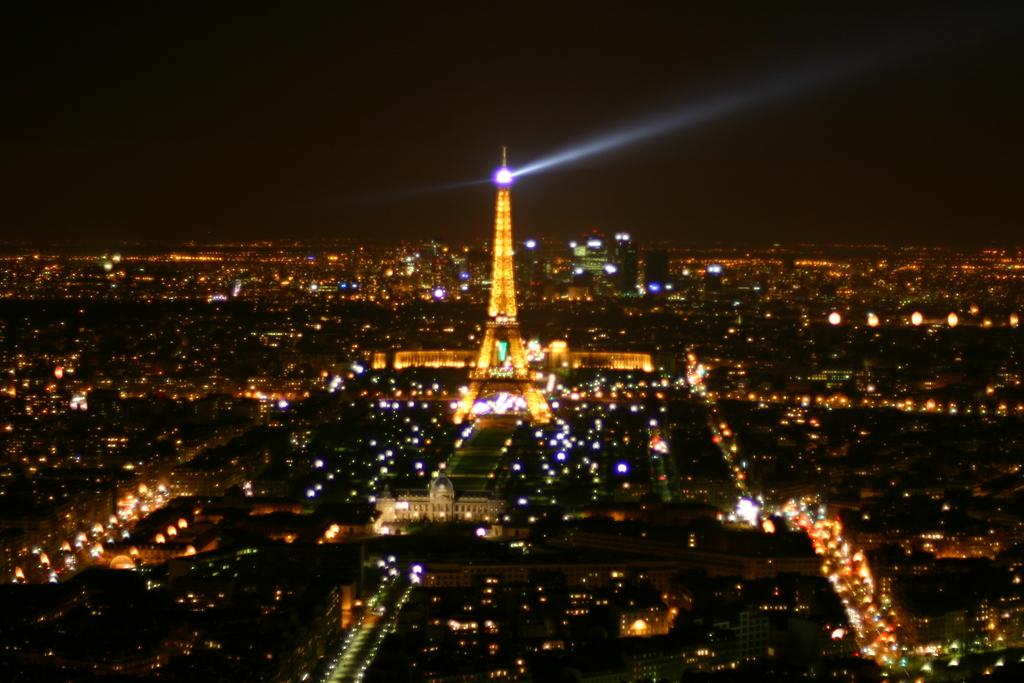What is the lighting condition in the image? The image was taken in the dark. Where was the image taken? It is an outside view. What is the main subject in the image? There is a tower in the middle of the image. What else can be seen in the image besides the tower? There are many buildings visible around the tower. What is the source of illumination in the image? Lights are present in the image. What degree of stretch can be seen in the image? There is no stretch present in the image, as it is a photograph and not a physical object. 